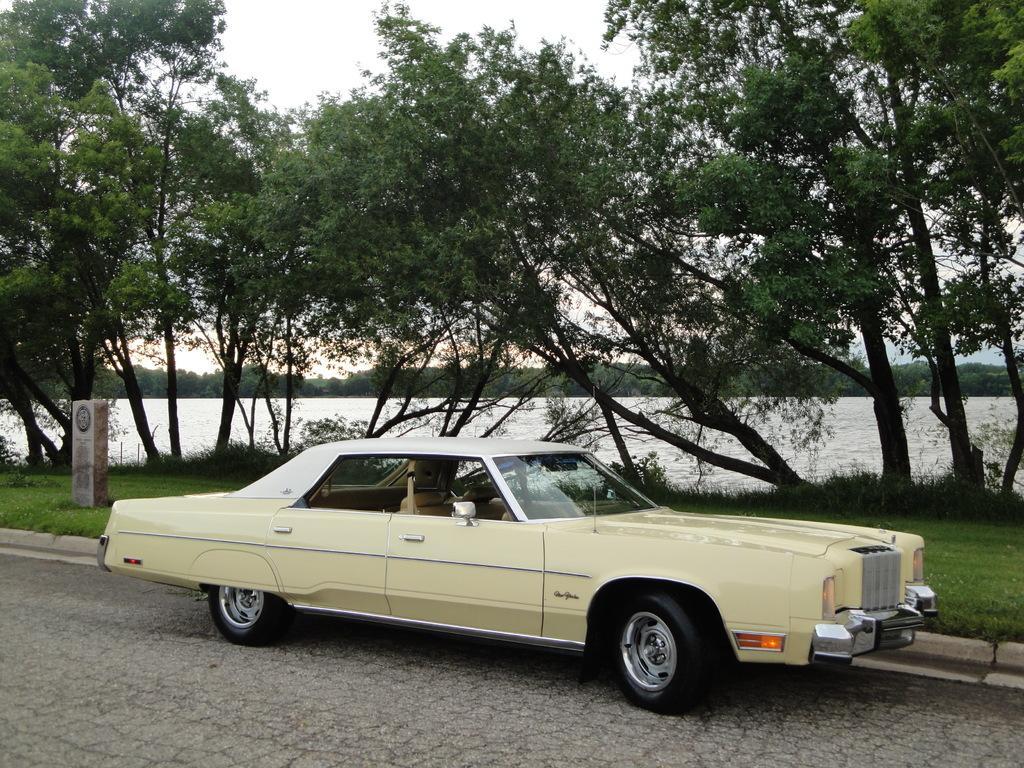Describe this image in one or two sentences. In the center of the image we can see a car on the road. In the background there is grass, trees, river and sky. 